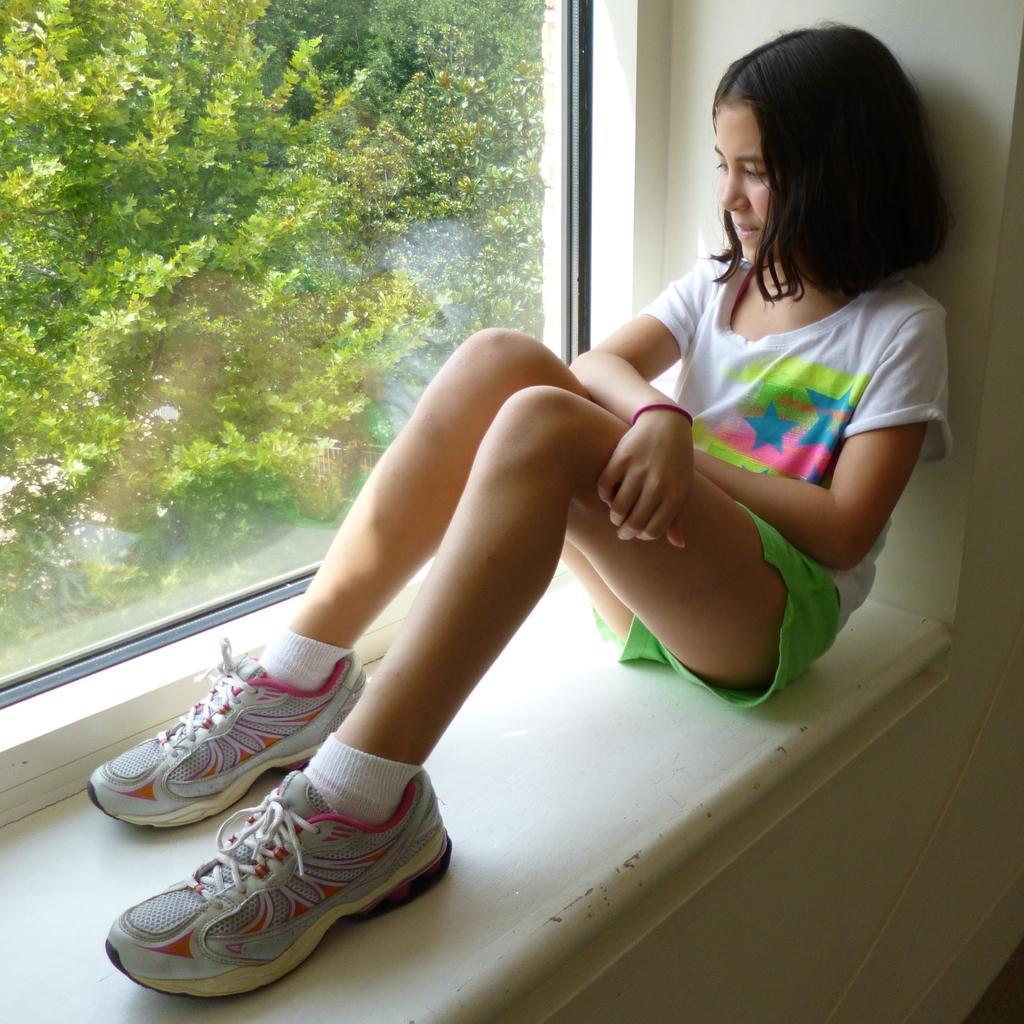Please provide a concise description of this image. In this image I can see the person sitting and the person is wearing white and green color dress. In the background I can see the glass window and few trees in green color. 